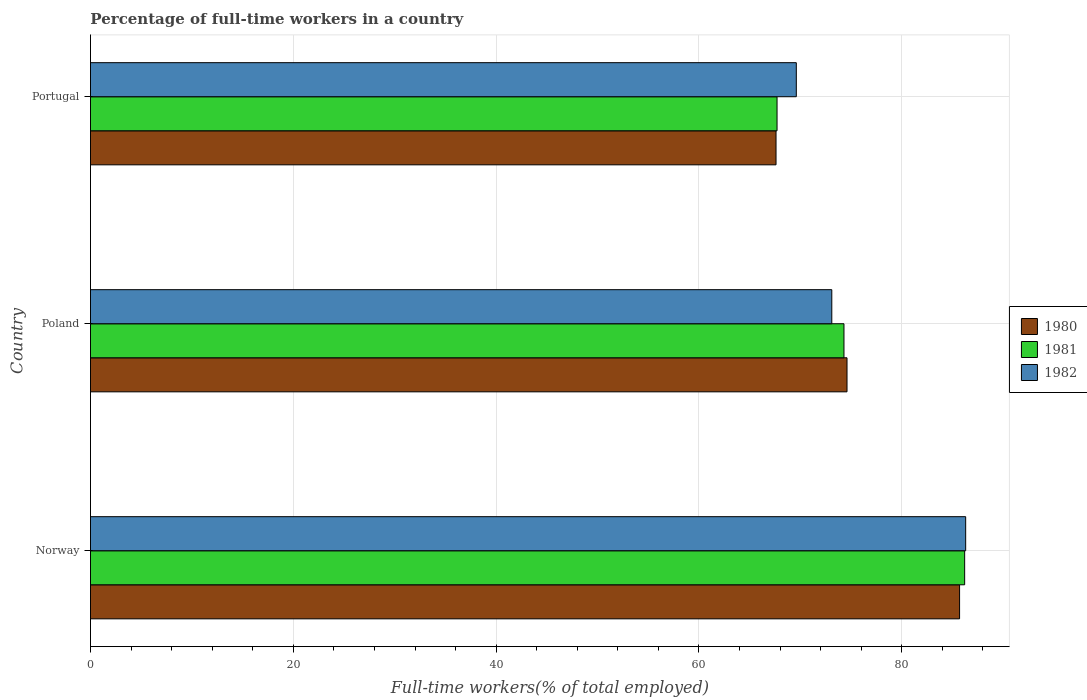How many different coloured bars are there?
Provide a succinct answer. 3. What is the percentage of full-time workers in 1980 in Portugal?
Provide a succinct answer. 67.6. Across all countries, what is the maximum percentage of full-time workers in 1980?
Provide a succinct answer. 85.7. Across all countries, what is the minimum percentage of full-time workers in 1981?
Provide a succinct answer. 67.7. In which country was the percentage of full-time workers in 1982 maximum?
Ensure brevity in your answer.  Norway. What is the total percentage of full-time workers in 1982 in the graph?
Offer a terse response. 229. What is the difference between the percentage of full-time workers in 1982 in Norway and that in Poland?
Ensure brevity in your answer.  13.2. What is the difference between the percentage of full-time workers in 1982 in Norway and the percentage of full-time workers in 1980 in Portugal?
Provide a succinct answer. 18.7. What is the average percentage of full-time workers in 1981 per country?
Give a very brief answer. 76.07. What is the ratio of the percentage of full-time workers in 1981 in Norway to that in Portugal?
Keep it short and to the point. 1.27. Is the percentage of full-time workers in 1981 in Norway less than that in Portugal?
Offer a very short reply. No. What is the difference between the highest and the second highest percentage of full-time workers in 1982?
Provide a short and direct response. 13.2. In how many countries, is the percentage of full-time workers in 1982 greater than the average percentage of full-time workers in 1982 taken over all countries?
Provide a short and direct response. 1. Is the sum of the percentage of full-time workers in 1982 in Poland and Portugal greater than the maximum percentage of full-time workers in 1981 across all countries?
Provide a succinct answer. Yes. What does the 1st bar from the top in Norway represents?
Keep it short and to the point. 1982. Does the graph contain any zero values?
Provide a succinct answer. No. Does the graph contain grids?
Give a very brief answer. Yes. How are the legend labels stacked?
Give a very brief answer. Vertical. What is the title of the graph?
Provide a short and direct response. Percentage of full-time workers in a country. What is the label or title of the X-axis?
Make the answer very short. Full-time workers(% of total employed). What is the label or title of the Y-axis?
Your answer should be compact. Country. What is the Full-time workers(% of total employed) of 1980 in Norway?
Offer a very short reply. 85.7. What is the Full-time workers(% of total employed) in 1981 in Norway?
Ensure brevity in your answer.  86.2. What is the Full-time workers(% of total employed) of 1982 in Norway?
Make the answer very short. 86.3. What is the Full-time workers(% of total employed) in 1980 in Poland?
Your answer should be compact. 74.6. What is the Full-time workers(% of total employed) in 1981 in Poland?
Offer a very short reply. 74.3. What is the Full-time workers(% of total employed) in 1982 in Poland?
Provide a short and direct response. 73.1. What is the Full-time workers(% of total employed) in 1980 in Portugal?
Your answer should be compact. 67.6. What is the Full-time workers(% of total employed) in 1981 in Portugal?
Keep it short and to the point. 67.7. What is the Full-time workers(% of total employed) in 1982 in Portugal?
Offer a terse response. 69.6. Across all countries, what is the maximum Full-time workers(% of total employed) of 1980?
Make the answer very short. 85.7. Across all countries, what is the maximum Full-time workers(% of total employed) of 1981?
Provide a succinct answer. 86.2. Across all countries, what is the maximum Full-time workers(% of total employed) in 1982?
Give a very brief answer. 86.3. Across all countries, what is the minimum Full-time workers(% of total employed) of 1980?
Make the answer very short. 67.6. Across all countries, what is the minimum Full-time workers(% of total employed) of 1981?
Give a very brief answer. 67.7. Across all countries, what is the minimum Full-time workers(% of total employed) in 1982?
Offer a terse response. 69.6. What is the total Full-time workers(% of total employed) in 1980 in the graph?
Provide a succinct answer. 227.9. What is the total Full-time workers(% of total employed) in 1981 in the graph?
Keep it short and to the point. 228.2. What is the total Full-time workers(% of total employed) of 1982 in the graph?
Offer a very short reply. 229. What is the difference between the Full-time workers(% of total employed) in 1982 in Norway and that in Poland?
Keep it short and to the point. 13.2. What is the difference between the Full-time workers(% of total employed) of 1981 in Poland and that in Portugal?
Provide a succinct answer. 6.6. What is the difference between the Full-time workers(% of total employed) of 1980 in Norway and the Full-time workers(% of total employed) of 1981 in Poland?
Provide a succinct answer. 11.4. What is the difference between the Full-time workers(% of total employed) in 1980 in Norway and the Full-time workers(% of total employed) in 1982 in Poland?
Provide a succinct answer. 12.6. What is the difference between the Full-time workers(% of total employed) in 1981 in Norway and the Full-time workers(% of total employed) in 1982 in Poland?
Keep it short and to the point. 13.1. What is the difference between the Full-time workers(% of total employed) of 1980 in Norway and the Full-time workers(% of total employed) of 1981 in Portugal?
Provide a short and direct response. 18. What is the difference between the Full-time workers(% of total employed) of 1980 in Norway and the Full-time workers(% of total employed) of 1982 in Portugal?
Your answer should be very brief. 16.1. What is the difference between the Full-time workers(% of total employed) in 1981 in Norway and the Full-time workers(% of total employed) in 1982 in Portugal?
Provide a short and direct response. 16.6. What is the difference between the Full-time workers(% of total employed) in 1980 in Poland and the Full-time workers(% of total employed) in 1981 in Portugal?
Offer a very short reply. 6.9. What is the difference between the Full-time workers(% of total employed) in 1981 in Poland and the Full-time workers(% of total employed) in 1982 in Portugal?
Your response must be concise. 4.7. What is the average Full-time workers(% of total employed) in 1980 per country?
Provide a short and direct response. 75.97. What is the average Full-time workers(% of total employed) in 1981 per country?
Your response must be concise. 76.07. What is the average Full-time workers(% of total employed) in 1982 per country?
Ensure brevity in your answer.  76.33. What is the difference between the Full-time workers(% of total employed) of 1980 and Full-time workers(% of total employed) of 1981 in Poland?
Give a very brief answer. 0.3. What is the difference between the Full-time workers(% of total employed) of 1980 and Full-time workers(% of total employed) of 1982 in Poland?
Make the answer very short. 1.5. What is the difference between the Full-time workers(% of total employed) in 1981 and Full-time workers(% of total employed) in 1982 in Poland?
Your answer should be very brief. 1.2. What is the difference between the Full-time workers(% of total employed) of 1980 and Full-time workers(% of total employed) of 1981 in Portugal?
Give a very brief answer. -0.1. What is the ratio of the Full-time workers(% of total employed) of 1980 in Norway to that in Poland?
Ensure brevity in your answer.  1.15. What is the ratio of the Full-time workers(% of total employed) in 1981 in Norway to that in Poland?
Provide a short and direct response. 1.16. What is the ratio of the Full-time workers(% of total employed) in 1982 in Norway to that in Poland?
Your answer should be compact. 1.18. What is the ratio of the Full-time workers(% of total employed) of 1980 in Norway to that in Portugal?
Give a very brief answer. 1.27. What is the ratio of the Full-time workers(% of total employed) in 1981 in Norway to that in Portugal?
Ensure brevity in your answer.  1.27. What is the ratio of the Full-time workers(% of total employed) in 1982 in Norway to that in Portugal?
Give a very brief answer. 1.24. What is the ratio of the Full-time workers(% of total employed) in 1980 in Poland to that in Portugal?
Your answer should be very brief. 1.1. What is the ratio of the Full-time workers(% of total employed) in 1981 in Poland to that in Portugal?
Ensure brevity in your answer.  1.1. What is the ratio of the Full-time workers(% of total employed) of 1982 in Poland to that in Portugal?
Provide a short and direct response. 1.05. What is the difference between the highest and the second highest Full-time workers(% of total employed) of 1980?
Offer a very short reply. 11.1. What is the difference between the highest and the lowest Full-time workers(% of total employed) of 1980?
Your answer should be compact. 18.1. What is the difference between the highest and the lowest Full-time workers(% of total employed) of 1981?
Offer a terse response. 18.5. 